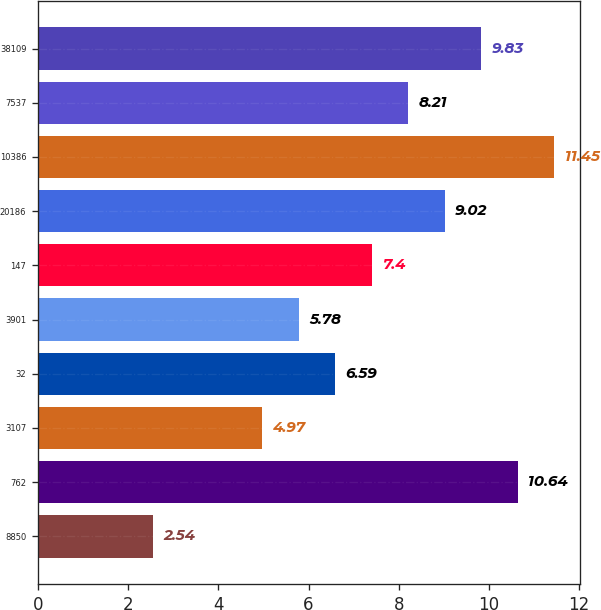<chart> <loc_0><loc_0><loc_500><loc_500><bar_chart><fcel>8850<fcel>762<fcel>3107<fcel>32<fcel>3901<fcel>147<fcel>20186<fcel>10386<fcel>7537<fcel>38109<nl><fcel>2.54<fcel>10.64<fcel>4.97<fcel>6.59<fcel>5.78<fcel>7.4<fcel>9.02<fcel>11.45<fcel>8.21<fcel>9.83<nl></chart> 